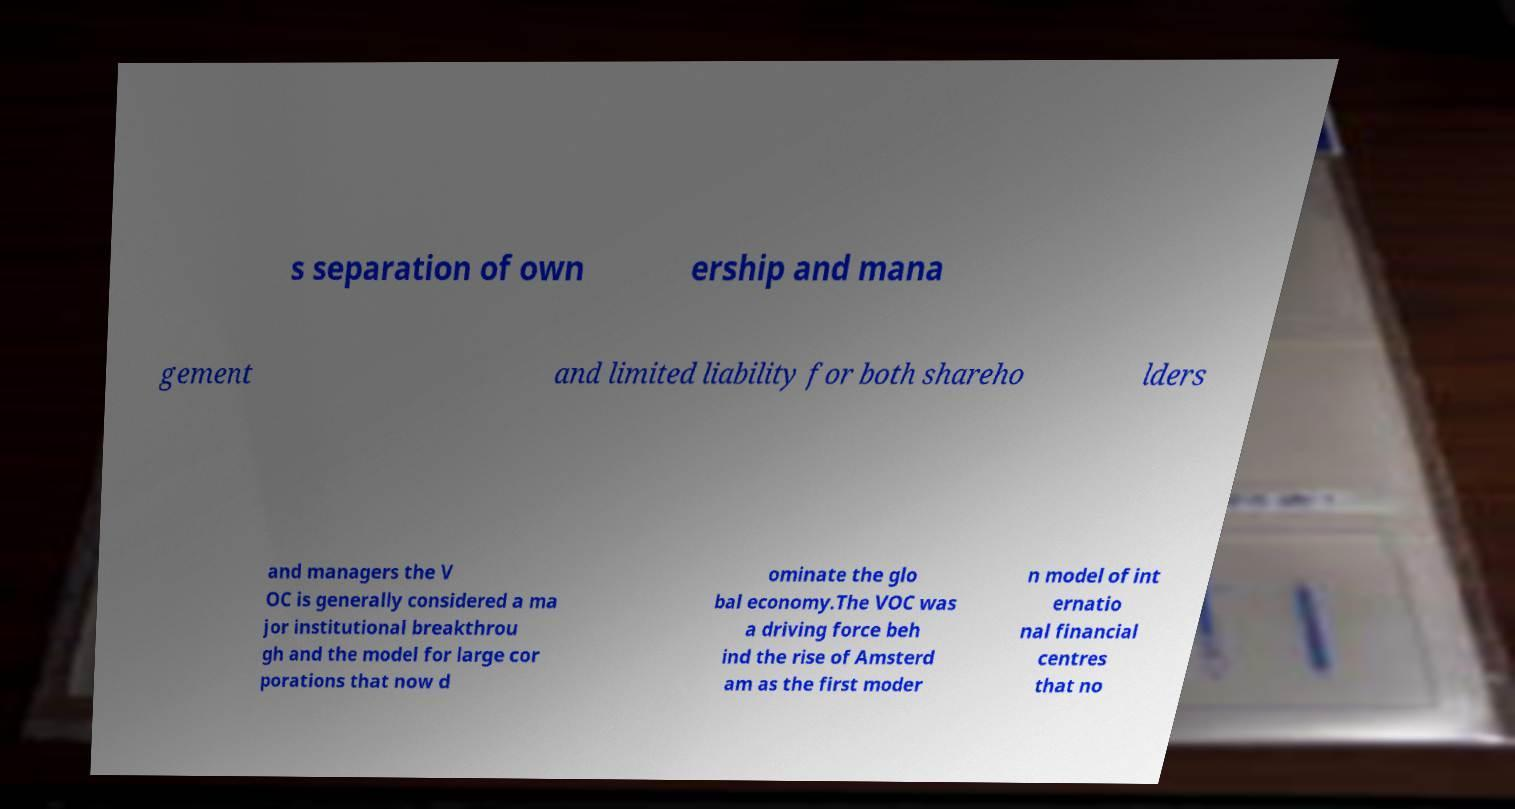I need the written content from this picture converted into text. Can you do that? s separation of own ership and mana gement and limited liability for both shareho lders and managers the V OC is generally considered a ma jor institutional breakthrou gh and the model for large cor porations that now d ominate the glo bal economy.The VOC was a driving force beh ind the rise of Amsterd am as the first moder n model of int ernatio nal financial centres that no 